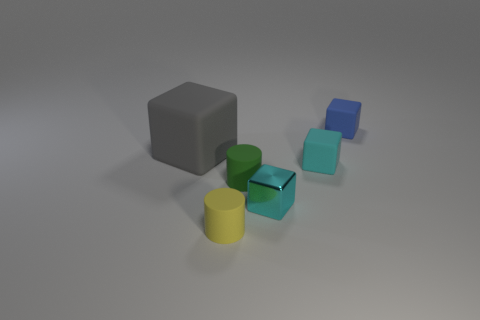Is there anything else that has the same size as the gray matte thing?
Ensure brevity in your answer.  No. Are there fewer tiny blue matte things that are in front of the green cylinder than tiny yellow rubber cylinders on the left side of the small cyan metal block?
Offer a terse response. Yes. There is a tiny object that is on the left side of the metal block and behind the tiny cyan shiny cube; what shape is it?
Offer a very short reply. Cylinder. What size is the cylinder that is the same material as the tiny green thing?
Give a very brief answer. Small. Does the metallic block have the same color as the rubber thing in front of the small green cylinder?
Provide a short and direct response. No. There is a object that is on the right side of the cyan shiny object and in front of the big gray block; what is its material?
Provide a succinct answer. Rubber. The rubber thing that is the same color as the metal block is what size?
Provide a succinct answer. Small. Is the shape of the blue thing that is behind the small yellow matte cylinder the same as the tiny cyan thing that is behind the small green matte cylinder?
Provide a short and direct response. Yes. Are any small yellow matte objects visible?
Offer a very short reply. Yes. There is another small rubber thing that is the same shape as the blue object; what color is it?
Offer a very short reply. Cyan. 